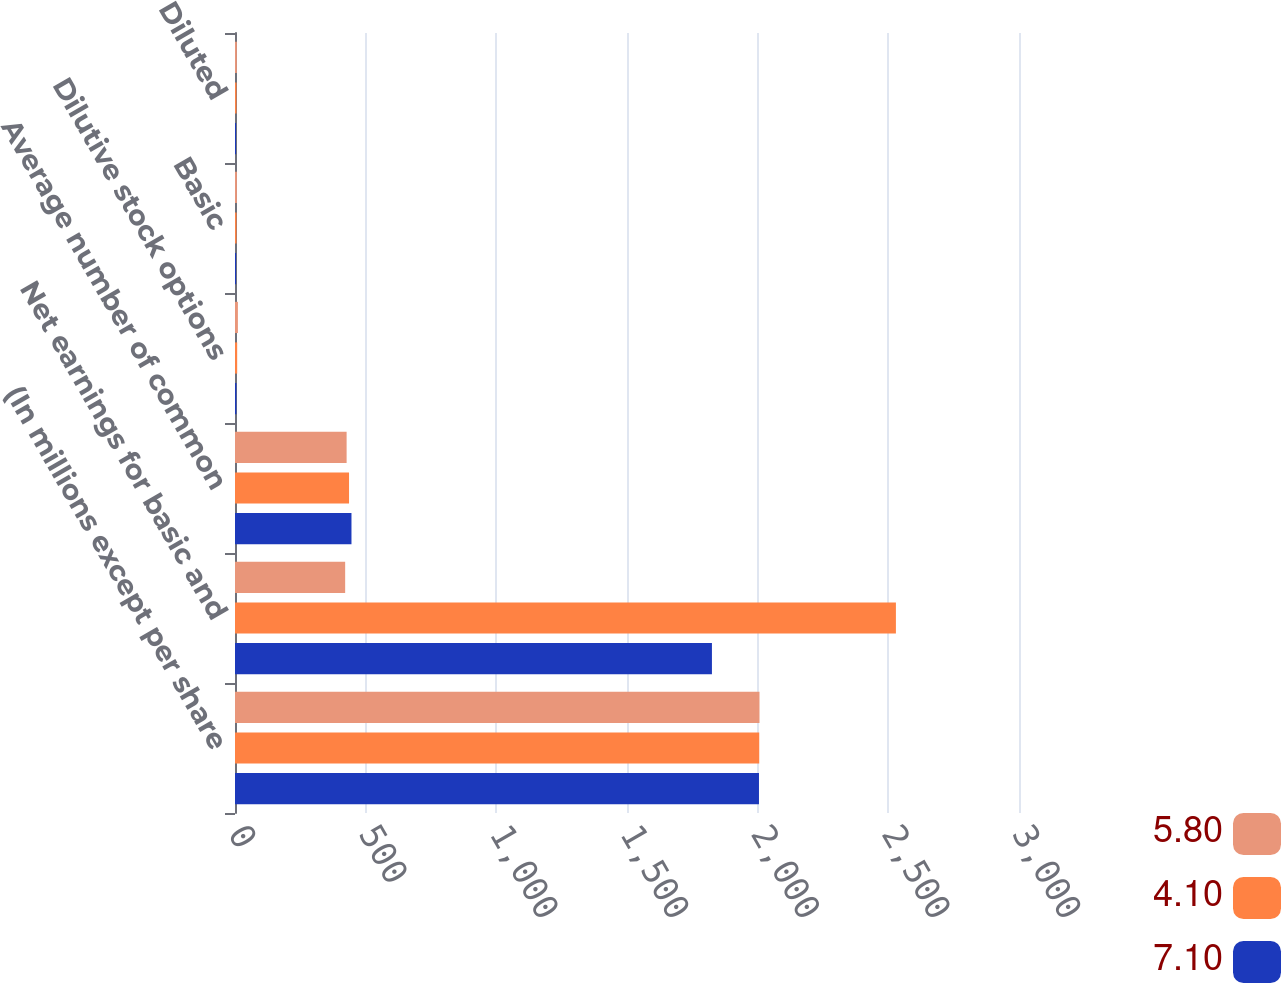Convert chart. <chart><loc_0><loc_0><loc_500><loc_500><stacked_bar_chart><ecel><fcel>(In millions except per share<fcel>Net earnings for basic and<fcel>Average number of common<fcel>Dilutive stock options<fcel>Basic<fcel>Diluted<nl><fcel>5.8<fcel>2007<fcel>421.55<fcel>427.1<fcel>11.1<fcel>7.29<fcel>7.1<nl><fcel>4.1<fcel>2006<fcel>2529<fcel>436.4<fcel>8.3<fcel>5.91<fcel>5.8<nl><fcel>7.1<fcel>2005<fcel>1825<fcel>445.7<fcel>5.4<fcel>4.15<fcel>4.1<nl></chart> 